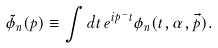Convert formula to latex. <formula><loc_0><loc_0><loc_500><loc_500>\tilde { \phi } _ { n } ( p ) \equiv \int d t \, e ^ { i p ^ { - } t } \phi _ { n } ( t , \alpha , \vec { p } ) .</formula> 